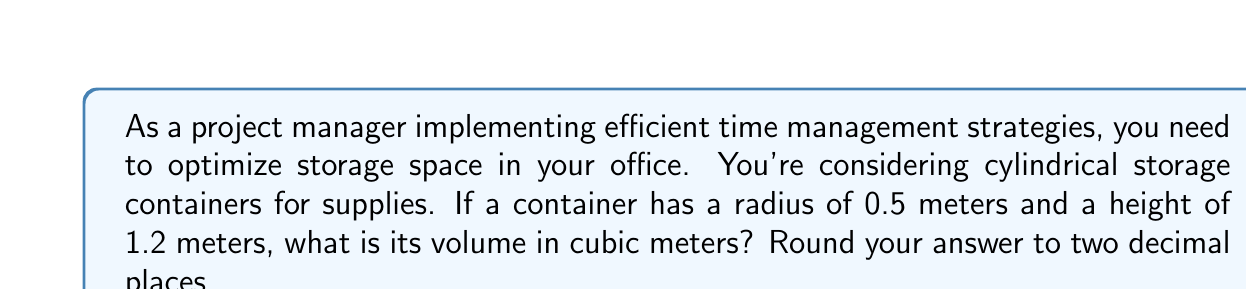Teach me how to tackle this problem. To calculate the volume of a cylindrical container, we use the formula:

$$V = \pi r^2 h$$

Where:
$V$ = volume
$\pi$ = pi (approximately 3.14159)
$r$ = radius of the base
$h$ = height of the cylinder

Given:
$r = 0.5$ meters
$h = 1.2$ meters

Let's substitute these values into the formula:

$$V = \pi (0.5)^2 (1.2)$$

Now, let's calculate step by step:

1. Calculate $r^2$:
   $$(0.5)^2 = 0.25$$

2. Multiply by $\pi$:
   $$\pi (0.25) \approx 0.7853981634$$

3. Multiply by the height:
   $$0.7853981634 \times 1.2 = 0.9424777961$$

4. Round to two decimal places:
   $$0.94 \text{ cubic meters}$$

[asy]
import geometry;

size(200);
real r = 50;
real h = 120;

path base = circle((0,0), r);
path top = circle((0,h), r);

draw(base);
draw(top);
draw((r,0)--(r,h));
draw((-r,0)--(-r,h));

label("r", (r/2,0), E);
label("h", (r,h/2), E);

draw((0,0)--(r,0), arrow=Arrow(TeXHead));
draw((r,0)--(r,h), arrow=Arrow(TeXHead));
[/asy]
Answer: $0.94 \text{ cubic meters}$ 